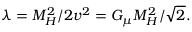Convert formula to latex. <formula><loc_0><loc_0><loc_500><loc_500>\lambda = M _ { H } ^ { 2 } / 2 v ^ { 2 } = G _ { \mu } M _ { H } ^ { 2 } / \sqrt { 2 } .</formula> 